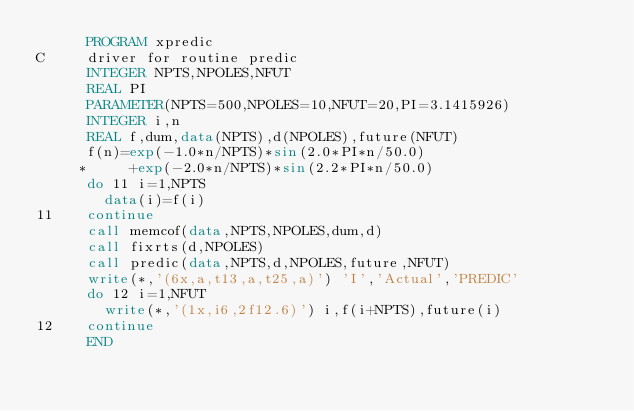Convert code to text. <code><loc_0><loc_0><loc_500><loc_500><_FORTRAN_>      PROGRAM xpredic
C     driver for routine predic
      INTEGER NPTS,NPOLES,NFUT
      REAL PI
      PARAMETER(NPTS=500,NPOLES=10,NFUT=20,PI=3.1415926)
      INTEGER i,n
      REAL f,dum,data(NPTS),d(NPOLES),future(NFUT)
      f(n)=exp(-1.0*n/NPTS)*sin(2.0*PI*n/50.0)
     *     +exp(-2.0*n/NPTS)*sin(2.2*PI*n/50.0)
      do 11 i=1,NPTS
        data(i)=f(i)
11    continue
      call memcof(data,NPTS,NPOLES,dum,d)
      call fixrts(d,NPOLES)
      call predic(data,NPTS,d,NPOLES,future,NFUT)
      write(*,'(6x,a,t13,a,t25,a)') 'I','Actual','PREDIC'
      do 12 i=1,NFUT
        write(*,'(1x,i6,2f12.6)') i,f(i+NPTS),future(i)
12    continue
      END
</code> 